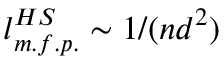Convert formula to latex. <formula><loc_0><loc_0><loc_500><loc_500>l _ { m . f . p . } ^ { H S } \sim 1 / ( n d ^ { 2 } )</formula> 